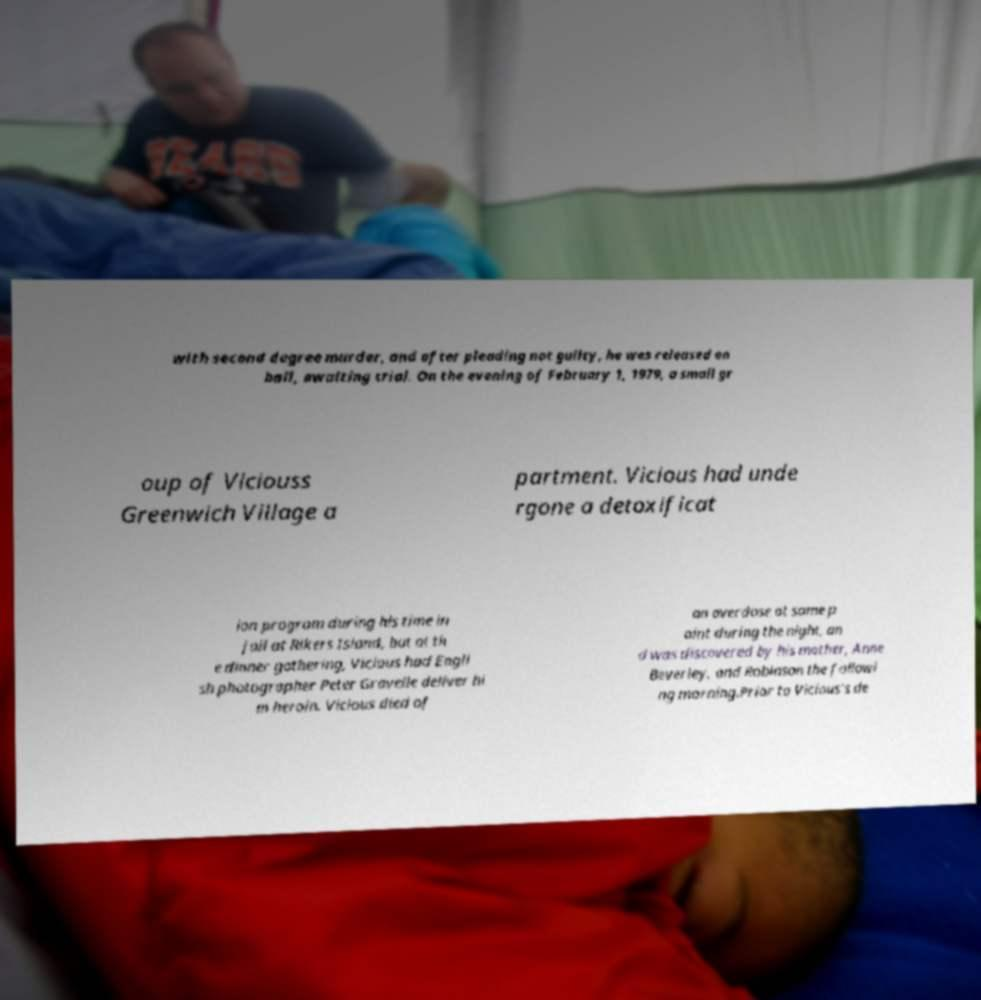Can you read and provide the text displayed in the image?This photo seems to have some interesting text. Can you extract and type it out for me? with second degree murder, and after pleading not guilty, he was released on bail, awaiting trial. On the evening of February 1, 1979, a small gr oup of Viciouss Greenwich Village a partment. Vicious had unde rgone a detoxificat ion program during his time in jail at Rikers Island, but at th e dinner gathering, Vicious had Engli sh photographer Peter Gravelle deliver hi m heroin. Vicious died of an overdose at some p oint during the night, an d was discovered by his mother, Anne Beverley, and Robinson the followi ng morning.Prior to Vicious's de 